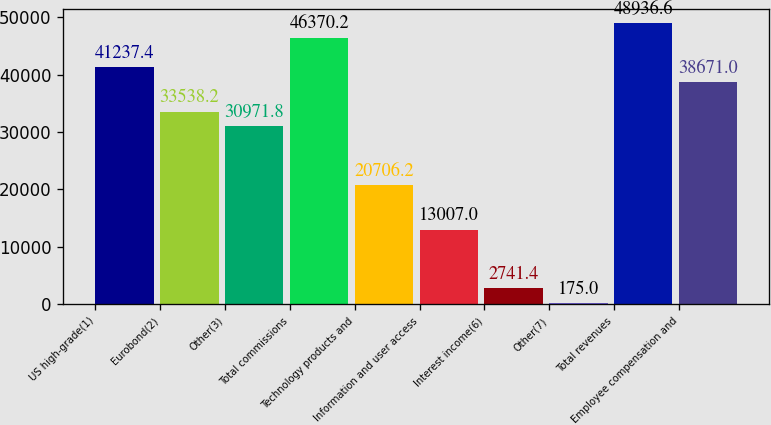Convert chart. <chart><loc_0><loc_0><loc_500><loc_500><bar_chart><fcel>US high-grade(1)<fcel>Eurobond(2)<fcel>Other(3)<fcel>Total commissions<fcel>Technology products and<fcel>Information and user access<fcel>Interest income(6)<fcel>Other(7)<fcel>Total revenues<fcel>Employee compensation and<nl><fcel>41237.4<fcel>33538.2<fcel>30971.8<fcel>46370.2<fcel>20706.2<fcel>13007<fcel>2741.4<fcel>175<fcel>48936.6<fcel>38671<nl></chart> 